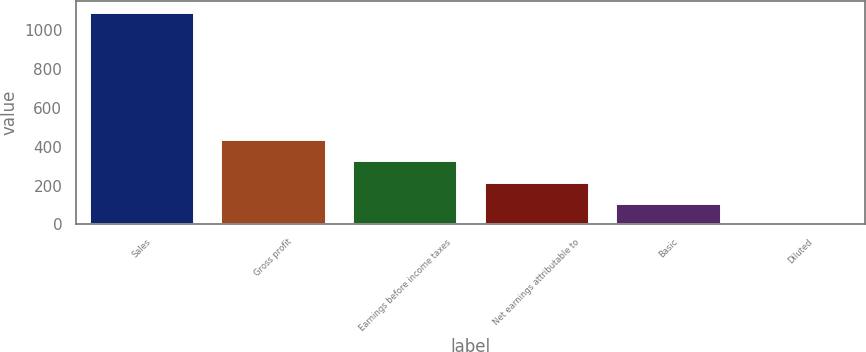Convert chart. <chart><loc_0><loc_0><loc_500><loc_500><bar_chart><fcel>Sales<fcel>Gross profit<fcel>Earnings before income taxes<fcel>Net earnings attributable to<fcel>Basic<fcel>Diluted<nl><fcel>1096.5<fcel>439.02<fcel>329.44<fcel>219.86<fcel>110.28<fcel>0.7<nl></chart> 